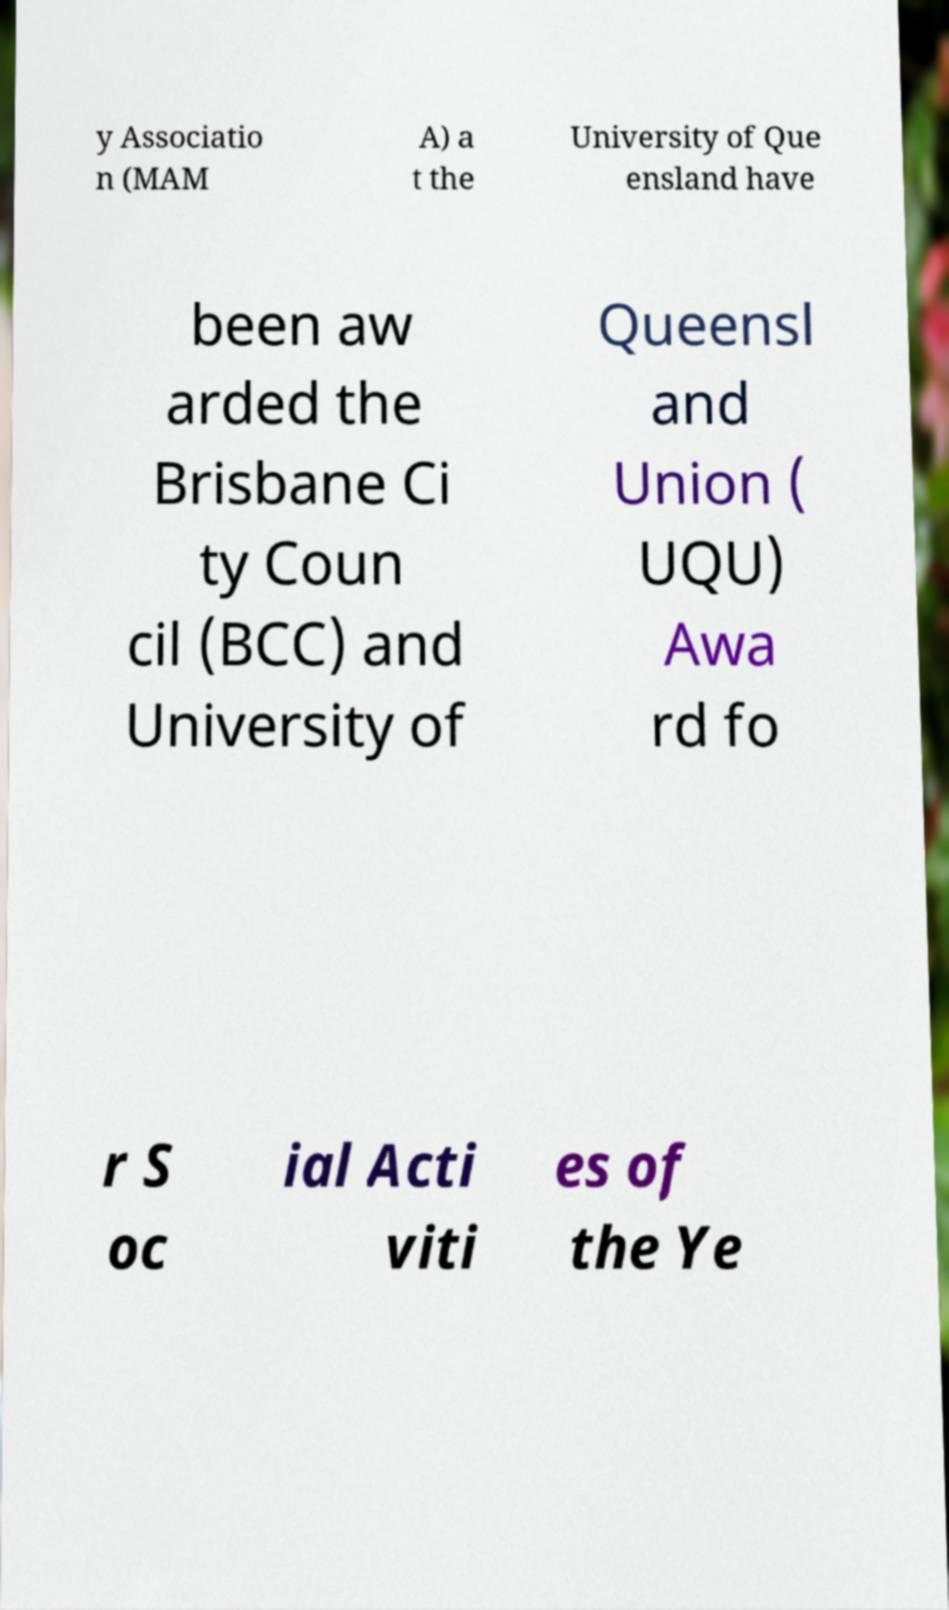Could you extract and type out the text from this image? y Associatio n (MAM A) a t the University of Que ensland have been aw arded the Brisbane Ci ty Coun cil (BCC) and University of Queensl and Union ( UQU) Awa rd fo r S oc ial Acti viti es of the Ye 